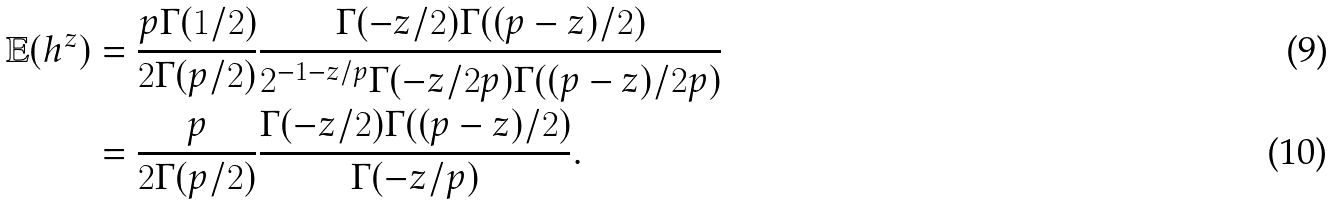<formula> <loc_0><loc_0><loc_500><loc_500>\mathbb { E } ( h ^ { z } ) & = \frac { p \Gamma ( 1 / 2 ) } { 2 \Gamma ( p / 2 ) } \frac { \Gamma ( - z / 2 ) \Gamma ( ( p - z ) / 2 ) } { 2 ^ { - 1 - z / p } \Gamma ( - z / 2 p ) \Gamma ( ( p - z ) / 2 p ) } \\ & = \frac { p } { 2 \Gamma ( p / 2 ) } \frac { \Gamma ( - z / 2 ) \Gamma ( ( p - z ) / 2 ) } { \Gamma ( - z / p ) } .</formula> 